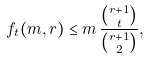<formula> <loc_0><loc_0><loc_500><loc_500>f _ { t } ( m , r ) \leq m \, \frac { \binom { r + 1 } { t } } { \binom { r + 1 } { 2 } } ,</formula> 